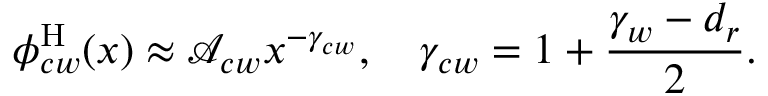<formula> <loc_0><loc_0><loc_500><loc_500>\phi _ { c w } ^ { H } ( x ) \approx \mathcal { A } _ { c w } x ^ { - \gamma _ { c w } } , \quad \gamma _ { c w } = 1 + \frac { \gamma _ { w } - { d _ { r } } } { 2 } .</formula> 